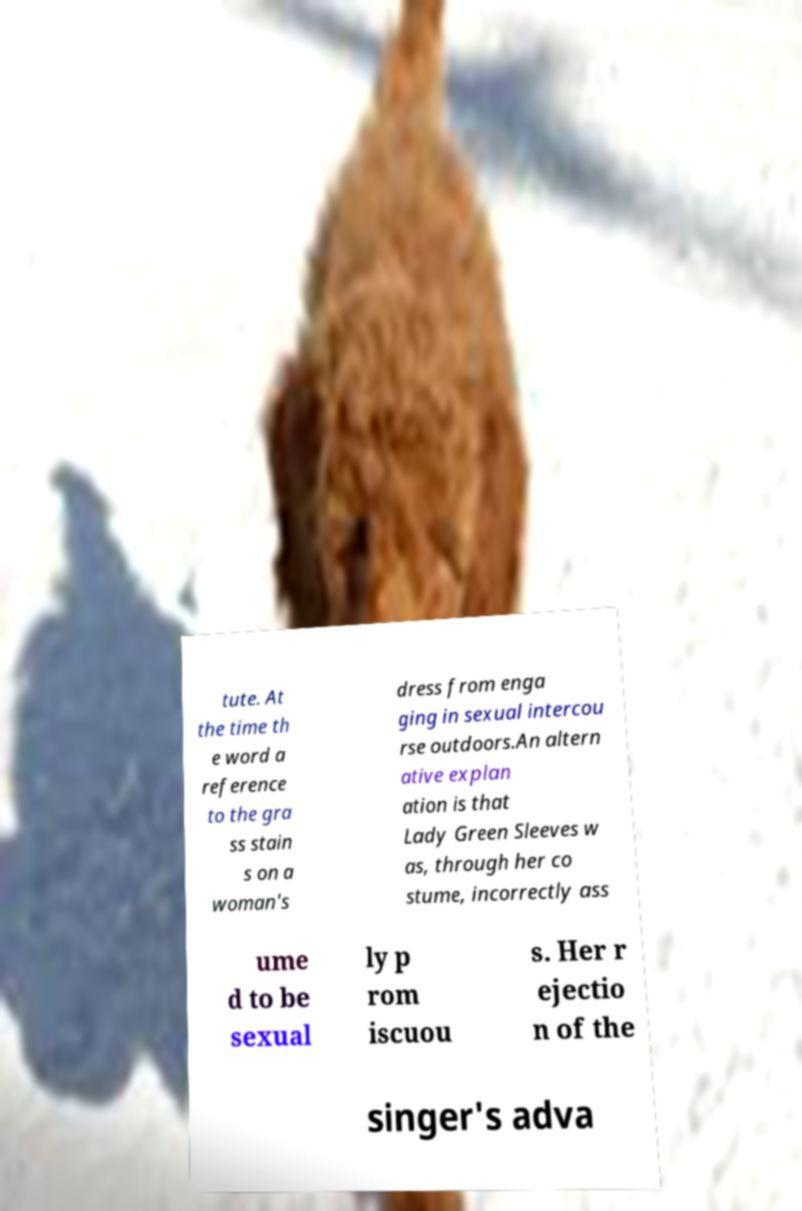Could you extract and type out the text from this image? tute. At the time th e word a reference to the gra ss stain s on a woman's dress from enga ging in sexual intercou rse outdoors.An altern ative explan ation is that Lady Green Sleeves w as, through her co stume, incorrectly ass ume d to be sexual ly p rom iscuou s. Her r ejectio n of the singer's adva 